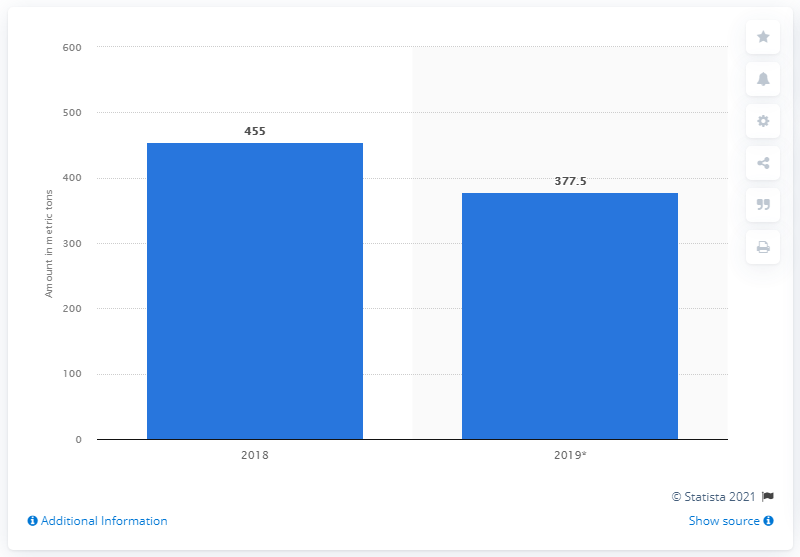Specify some key components in this picture. The amount of cocaine has decreased significantly from 2018 to 2019. In 2019, a total of 377.5 kilograms of cocaine was seized. 